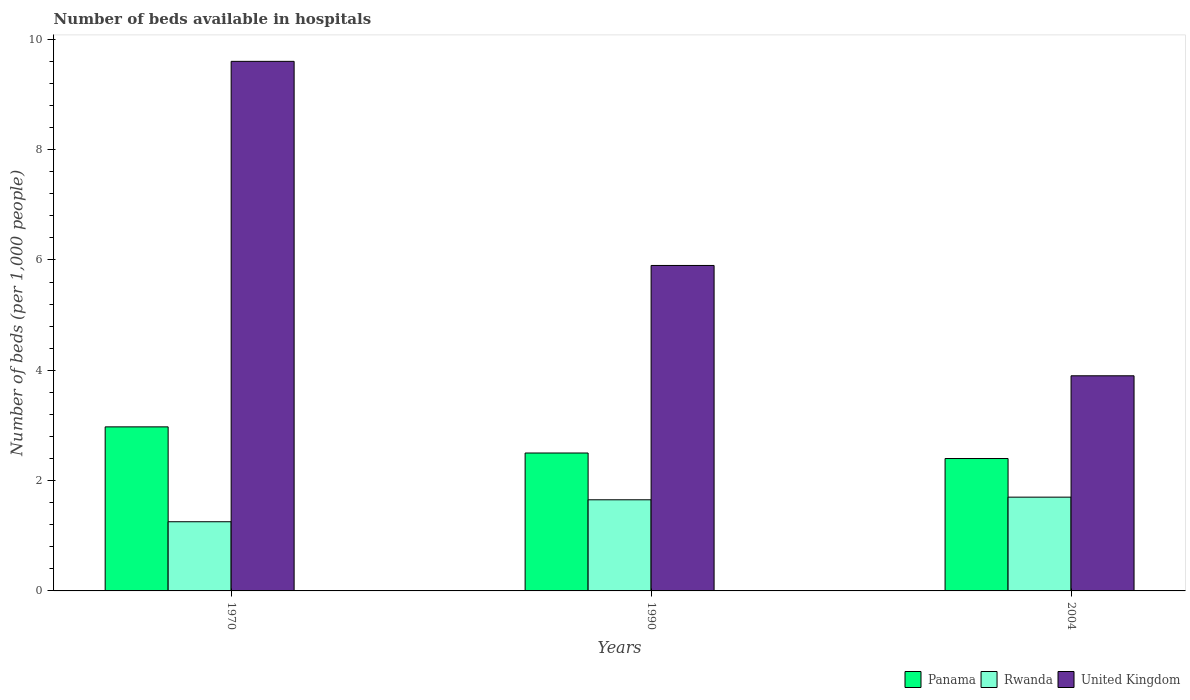How many different coloured bars are there?
Ensure brevity in your answer.  3. How many groups of bars are there?
Offer a very short reply. 3. Are the number of bars per tick equal to the number of legend labels?
Your answer should be very brief. Yes. How many bars are there on the 2nd tick from the right?
Your answer should be compact. 3. What is the label of the 3rd group of bars from the left?
Your answer should be very brief. 2004. What is the number of beds in the hospiatls of in United Kingdom in 1970?
Ensure brevity in your answer.  9.6. Across all years, what is the maximum number of beds in the hospiatls of in United Kingdom?
Your answer should be compact. 9.6. Across all years, what is the minimum number of beds in the hospiatls of in Rwanda?
Keep it short and to the point. 1.25. What is the total number of beds in the hospiatls of in Panama in the graph?
Provide a short and direct response. 7.87. What is the difference between the number of beds in the hospiatls of in United Kingdom in 1970 and that in 2004?
Your response must be concise. 5.7. What is the difference between the number of beds in the hospiatls of in Panama in 1970 and the number of beds in the hospiatls of in United Kingdom in 2004?
Offer a terse response. -0.93. What is the average number of beds in the hospiatls of in Rwanda per year?
Provide a succinct answer. 1.54. In how many years, is the number of beds in the hospiatls of in Rwanda greater than 6.8?
Your answer should be compact. 0. What is the ratio of the number of beds in the hospiatls of in Panama in 1990 to that in 2004?
Offer a terse response. 1.04. Is the number of beds in the hospiatls of in United Kingdom in 1970 less than that in 1990?
Provide a succinct answer. No. What is the difference between the highest and the second highest number of beds in the hospiatls of in United Kingdom?
Provide a short and direct response. 3.7. What is the difference between the highest and the lowest number of beds in the hospiatls of in Rwanda?
Keep it short and to the point. 0.45. What does the 3rd bar from the right in 1990 represents?
Make the answer very short. Panama. Is it the case that in every year, the sum of the number of beds in the hospiatls of in Rwanda and number of beds in the hospiatls of in United Kingdom is greater than the number of beds in the hospiatls of in Panama?
Your answer should be compact. Yes. How many bars are there?
Make the answer very short. 9. Are all the bars in the graph horizontal?
Your answer should be compact. No. Are the values on the major ticks of Y-axis written in scientific E-notation?
Give a very brief answer. No. How many legend labels are there?
Offer a terse response. 3. What is the title of the graph?
Offer a terse response. Number of beds available in hospitals. What is the label or title of the X-axis?
Your answer should be compact. Years. What is the label or title of the Y-axis?
Ensure brevity in your answer.  Number of beds (per 1,0 people). What is the Number of beds (per 1,000 people) of Panama in 1970?
Make the answer very short. 2.97. What is the Number of beds (per 1,000 people) in Rwanda in 1970?
Your answer should be very brief. 1.25. What is the Number of beds (per 1,000 people) in United Kingdom in 1970?
Keep it short and to the point. 9.6. What is the Number of beds (per 1,000 people) in Rwanda in 1990?
Your answer should be compact. 1.65. What is the Number of beds (per 1,000 people) in United Kingdom in 1990?
Your answer should be compact. 5.9. What is the Number of beds (per 1,000 people) of Rwanda in 2004?
Ensure brevity in your answer.  1.7. What is the Number of beds (per 1,000 people) of United Kingdom in 2004?
Your response must be concise. 3.9. Across all years, what is the maximum Number of beds (per 1,000 people) of Panama?
Your answer should be compact. 2.97. Across all years, what is the maximum Number of beds (per 1,000 people) in United Kingdom?
Keep it short and to the point. 9.6. Across all years, what is the minimum Number of beds (per 1,000 people) of Rwanda?
Give a very brief answer. 1.25. What is the total Number of beds (per 1,000 people) of Panama in the graph?
Your answer should be very brief. 7.87. What is the total Number of beds (per 1,000 people) of Rwanda in the graph?
Offer a terse response. 4.61. What is the difference between the Number of beds (per 1,000 people) in Panama in 1970 and that in 1990?
Make the answer very short. 0.47. What is the difference between the Number of beds (per 1,000 people) in Rwanda in 1970 and that in 1990?
Your answer should be compact. -0.4. What is the difference between the Number of beds (per 1,000 people) in United Kingdom in 1970 and that in 1990?
Make the answer very short. 3.7. What is the difference between the Number of beds (per 1,000 people) in Panama in 1970 and that in 2004?
Give a very brief answer. 0.57. What is the difference between the Number of beds (per 1,000 people) of Rwanda in 1970 and that in 2004?
Your response must be concise. -0.45. What is the difference between the Number of beds (per 1,000 people) of Rwanda in 1990 and that in 2004?
Offer a terse response. -0.05. What is the difference between the Number of beds (per 1,000 people) of Panama in 1970 and the Number of beds (per 1,000 people) of Rwanda in 1990?
Offer a terse response. 1.32. What is the difference between the Number of beds (per 1,000 people) in Panama in 1970 and the Number of beds (per 1,000 people) in United Kingdom in 1990?
Provide a succinct answer. -2.93. What is the difference between the Number of beds (per 1,000 people) in Rwanda in 1970 and the Number of beds (per 1,000 people) in United Kingdom in 1990?
Offer a very short reply. -4.65. What is the difference between the Number of beds (per 1,000 people) of Panama in 1970 and the Number of beds (per 1,000 people) of Rwanda in 2004?
Give a very brief answer. 1.27. What is the difference between the Number of beds (per 1,000 people) of Panama in 1970 and the Number of beds (per 1,000 people) of United Kingdom in 2004?
Your answer should be very brief. -0.93. What is the difference between the Number of beds (per 1,000 people) in Rwanda in 1970 and the Number of beds (per 1,000 people) in United Kingdom in 2004?
Your answer should be very brief. -2.65. What is the difference between the Number of beds (per 1,000 people) of Panama in 1990 and the Number of beds (per 1,000 people) of United Kingdom in 2004?
Give a very brief answer. -1.4. What is the difference between the Number of beds (per 1,000 people) in Rwanda in 1990 and the Number of beds (per 1,000 people) in United Kingdom in 2004?
Keep it short and to the point. -2.25. What is the average Number of beds (per 1,000 people) of Panama per year?
Your response must be concise. 2.62. What is the average Number of beds (per 1,000 people) of Rwanda per year?
Keep it short and to the point. 1.54. What is the average Number of beds (per 1,000 people) of United Kingdom per year?
Your response must be concise. 6.47. In the year 1970, what is the difference between the Number of beds (per 1,000 people) in Panama and Number of beds (per 1,000 people) in Rwanda?
Provide a short and direct response. 1.72. In the year 1970, what is the difference between the Number of beds (per 1,000 people) in Panama and Number of beds (per 1,000 people) in United Kingdom?
Your answer should be compact. -6.63. In the year 1970, what is the difference between the Number of beds (per 1,000 people) in Rwanda and Number of beds (per 1,000 people) in United Kingdom?
Provide a succinct answer. -8.35. In the year 1990, what is the difference between the Number of beds (per 1,000 people) of Panama and Number of beds (per 1,000 people) of Rwanda?
Provide a short and direct response. 0.85. In the year 1990, what is the difference between the Number of beds (per 1,000 people) of Panama and Number of beds (per 1,000 people) of United Kingdom?
Offer a very short reply. -3.4. In the year 1990, what is the difference between the Number of beds (per 1,000 people) in Rwanda and Number of beds (per 1,000 people) in United Kingdom?
Offer a very short reply. -4.25. In the year 2004, what is the difference between the Number of beds (per 1,000 people) of Panama and Number of beds (per 1,000 people) of Rwanda?
Give a very brief answer. 0.7. In the year 2004, what is the difference between the Number of beds (per 1,000 people) in Rwanda and Number of beds (per 1,000 people) in United Kingdom?
Offer a very short reply. -2.2. What is the ratio of the Number of beds (per 1,000 people) in Panama in 1970 to that in 1990?
Provide a short and direct response. 1.19. What is the ratio of the Number of beds (per 1,000 people) in Rwanda in 1970 to that in 1990?
Your answer should be very brief. 0.76. What is the ratio of the Number of beds (per 1,000 people) of United Kingdom in 1970 to that in 1990?
Your response must be concise. 1.63. What is the ratio of the Number of beds (per 1,000 people) in Panama in 1970 to that in 2004?
Your answer should be compact. 1.24. What is the ratio of the Number of beds (per 1,000 people) in Rwanda in 1970 to that in 2004?
Give a very brief answer. 0.74. What is the ratio of the Number of beds (per 1,000 people) of United Kingdom in 1970 to that in 2004?
Your response must be concise. 2.46. What is the ratio of the Number of beds (per 1,000 people) of Panama in 1990 to that in 2004?
Your answer should be very brief. 1.04. What is the ratio of the Number of beds (per 1,000 people) of Rwanda in 1990 to that in 2004?
Offer a very short reply. 0.97. What is the ratio of the Number of beds (per 1,000 people) in United Kingdom in 1990 to that in 2004?
Offer a very short reply. 1.51. What is the difference between the highest and the second highest Number of beds (per 1,000 people) of Panama?
Offer a terse response. 0.47. What is the difference between the highest and the second highest Number of beds (per 1,000 people) in Rwanda?
Your answer should be very brief. 0.05. What is the difference between the highest and the second highest Number of beds (per 1,000 people) of United Kingdom?
Make the answer very short. 3.7. What is the difference between the highest and the lowest Number of beds (per 1,000 people) in Panama?
Your answer should be very brief. 0.57. What is the difference between the highest and the lowest Number of beds (per 1,000 people) in Rwanda?
Make the answer very short. 0.45. What is the difference between the highest and the lowest Number of beds (per 1,000 people) in United Kingdom?
Ensure brevity in your answer.  5.7. 